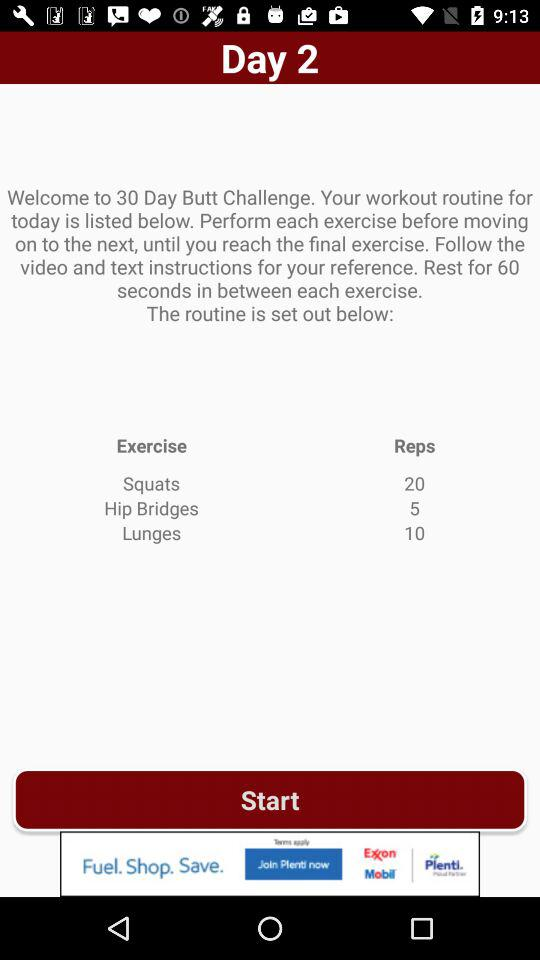What are the different types of exercises? The different types of exercises are "Squats", "Hip Bridges" and "Lunges". 